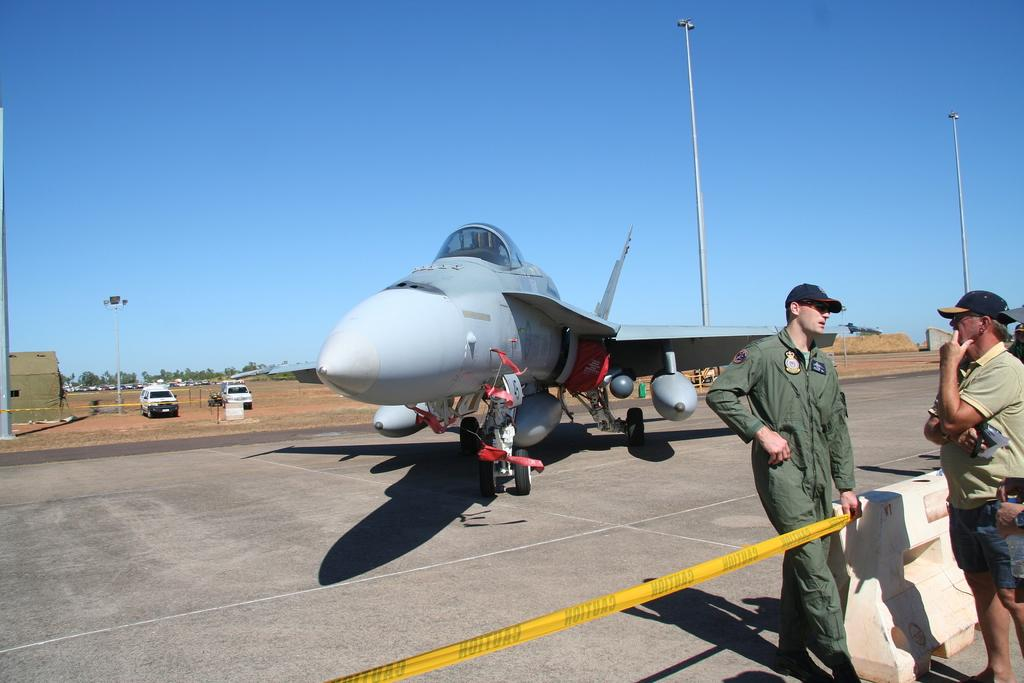What is the main subject of the image? The main subject of the image is an aircraft. Can you describe the people on the right side of the image? There are two people on the right side of the image. What else can be seen in the image besides the aircraft and people? There are vehicles visible in the image. What is visible in the background of the image? The sky is visible in the background of the image. What type of creature can be seen interacting with the memory in the image? There is no creature or memory present in the image; it features an aircraft and people. How does the image change over time? The image itself does not change over time; it is a static representation of the scene. 